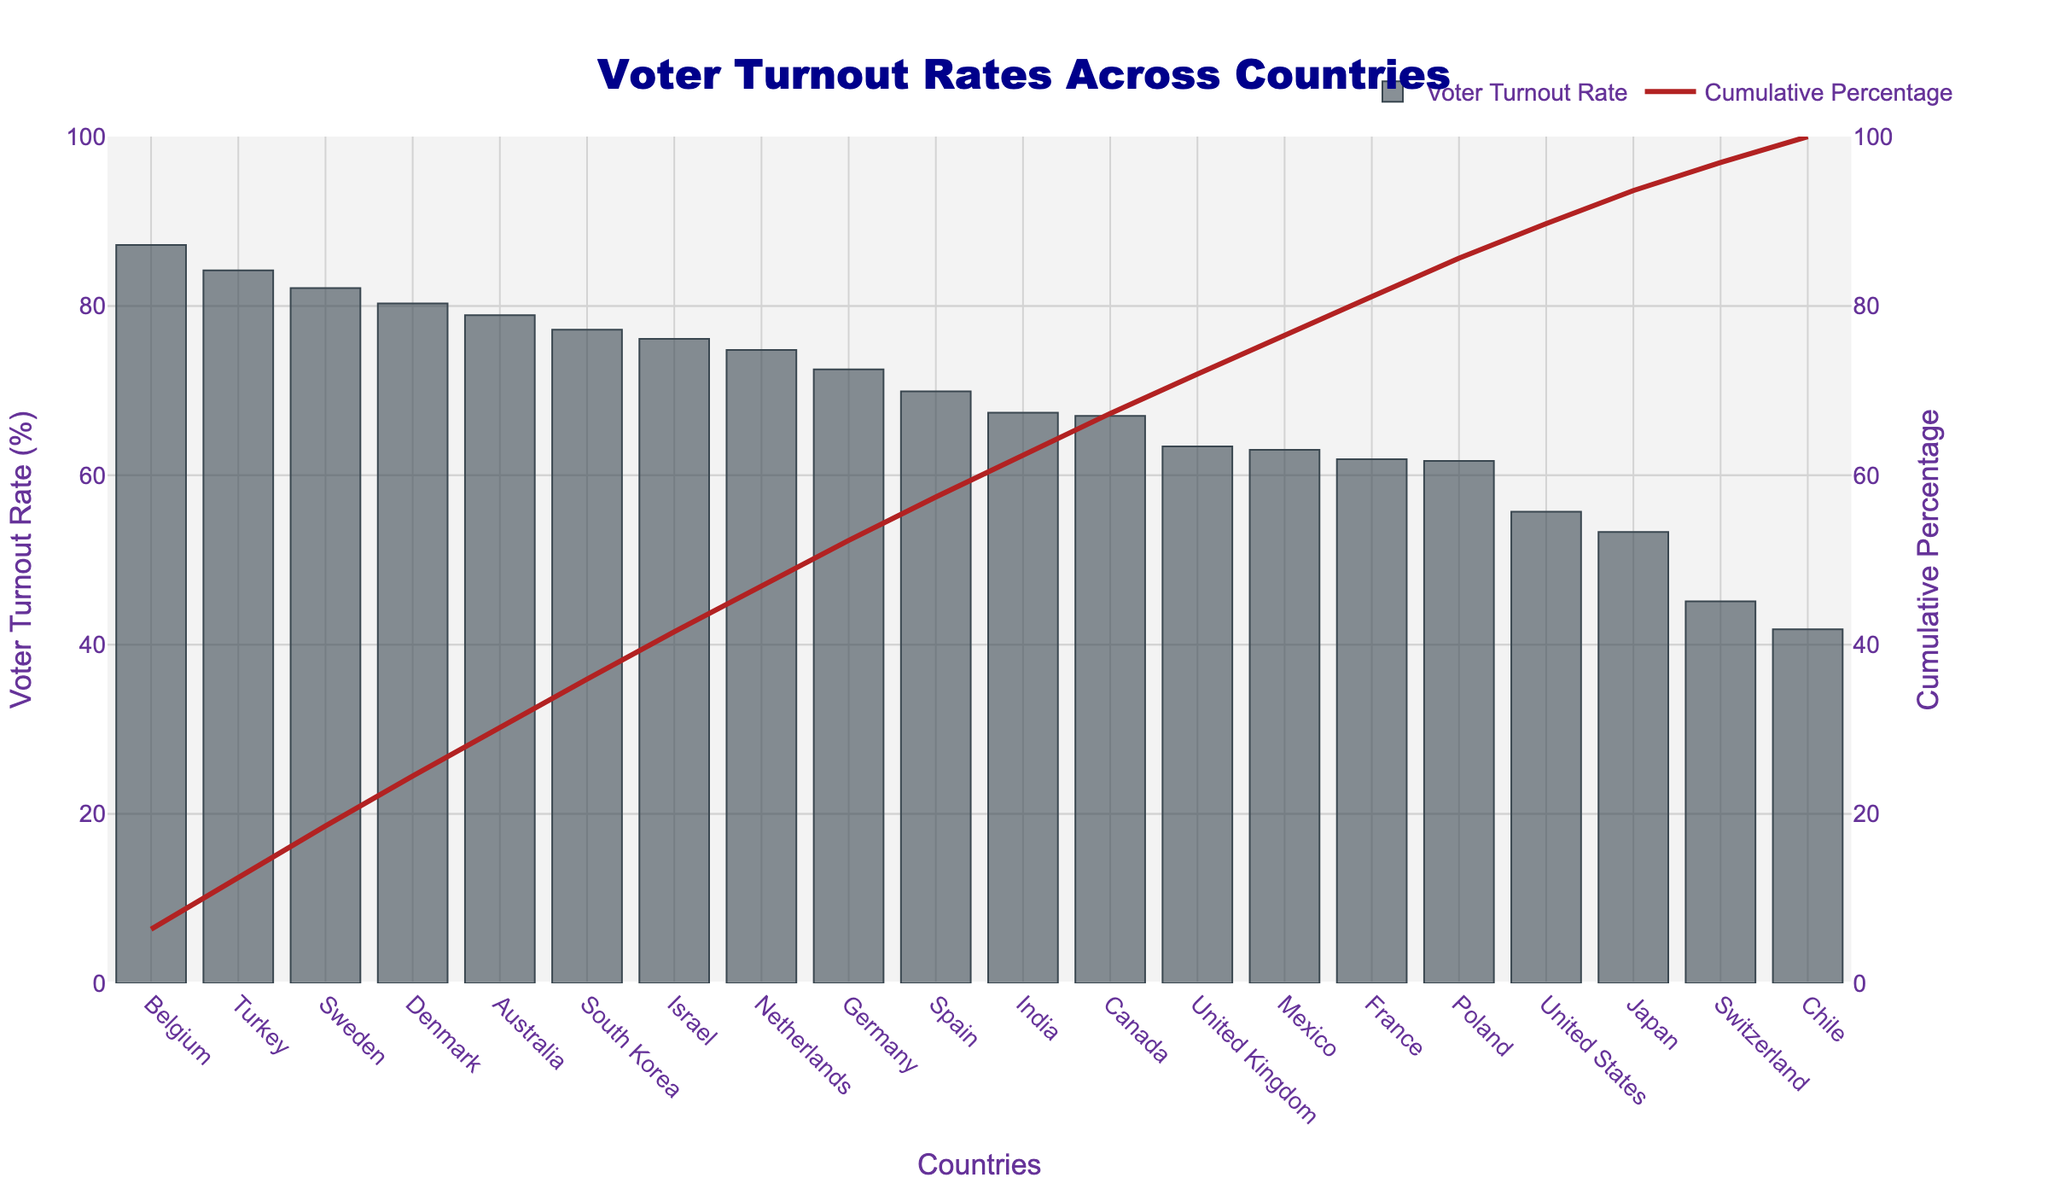What is the title of the figure? The title of the figure is displayed prominently at the top center of the chart. It reads "Voter Turnout Rates Across Countries".
Answer: Voter Turnout Rates Across Countries Which country has the highest voter turnout rate? The bar for Belgium is the tallest in the chart and appears first on the x-axis, indicating the highest voter turnout rate. The exact value shown is 87.2%.
Answer: Belgium How many countries have a voter turnout rate higher than 75%? To determine the number of countries with a voter turnout rate higher than 75%, look at all bars that exceed the 75% mark on the y-axis. These countries are Belgium, Sweden, Denmark, Australia, South Korea, Israel, and Turkey. Counting these gives us a total of 7 countries.
Answer: 7 What is the cumulative percentage after adding Germany's turnout rate? Find Germany on the x-axis and follow the line for that point in the cumulative percentage chart. The corresponding cumulative percentage value for Germany is around 76%.
Answer: 76% Which country has a lower voter turnout rate, the United States or India? Compare the heights of the bars for the United States and India. The United States has a voter turnout rate of 55.7%, whereas India has a higher turnout rate of 67.4%. Thus, the United States has a lower voter turnout rate.
Answer: United States What is the voter turnout rate of the country at the midpoint of the chart? With a total of 20 countries, the midpoint is the 10th country when ordered by descending voter turnout rate. Mexico is the 10th country, with a voter turnout rate of 63.0%.
Answer: 63.0% What is the range of voter turnout rates depicted in the chart? The range is calculated as the difference between the highest and lowest voter turnout rates. Belgium has the highest at 87.2%, and Chile has the lowest at 41.8%. Therefore, the range is 87.2% - 41.8% = 45.4%.
Answer: 45.4% Which country has the smallest increment in cumulative percentage when its voter turnout rate is added? Observe the changes in the cumulative percentage line and identify the smallest increase per addition of a country's turnout rate. This occurs for countries with lower turnout rates towards the end of the x-axis. Chile has the smallest increment on inspection.
Answer: Chile At what cumulative percentage does the chart reach after adding the first five countries? Add the voter turnout rates of Belgium, Sweden, Denmark, Australia, and South Korea: 87.2% + 82.1% + 80.3% + 78.9% + 77.2%. The cumulative percentage is calculated as (87.2 + 82.1 + 80.3 + 78.9 + 77.2) / (total enrollment of all countries) * 100, which approximates to 72%.
Answer: 72% How does the voter turnout rate of France compare to that of Poland? Compare the height of the bars for France and Poland. France has a voter turnout rate of 61.9%, whereas Poland has a close but slightly lower rate of 61.7%. Thus, France has a slightly higher voter turnout rate.
Answer: France 